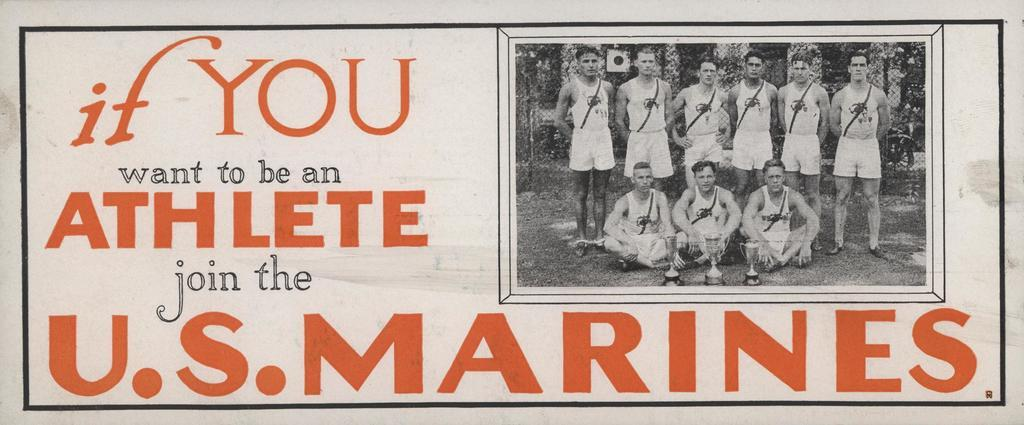<image>
Relay a brief, clear account of the picture shown. A sign stating if you want to be an athlete join the U.S. Marines. 